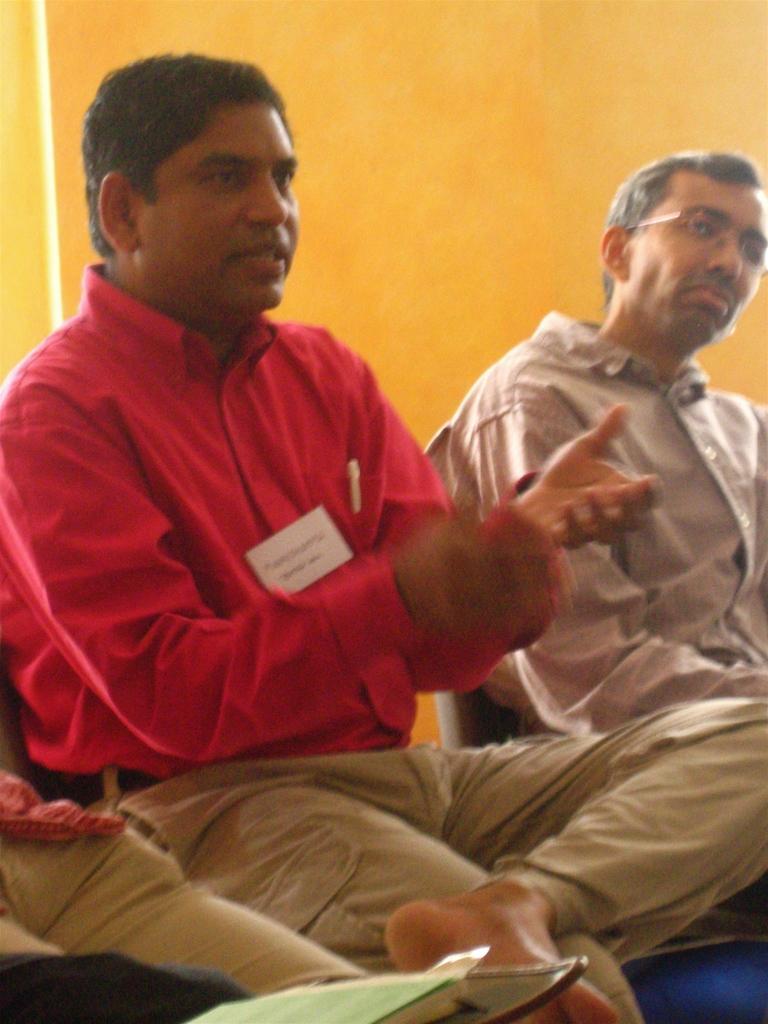Please provide a concise description of this image. In the picture we can see two men are sitting, one man is in a red shirt and he is talking and behind them we can see the wall which is yellow in color. 